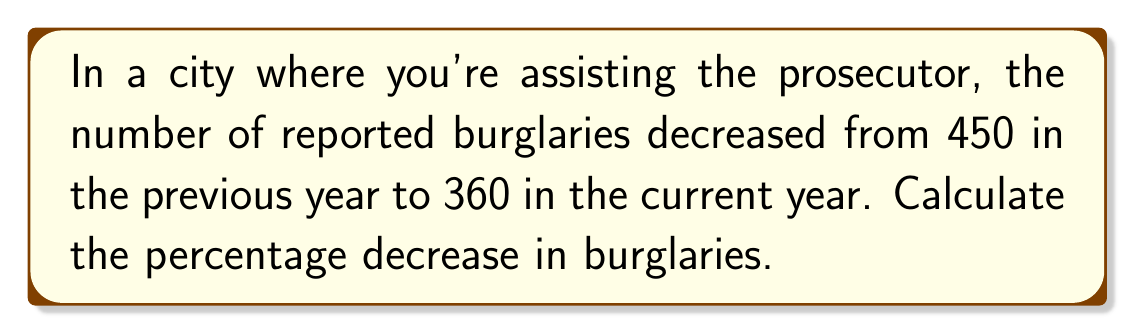Provide a solution to this math problem. To calculate the percentage decrease in burglaries, we'll follow these steps:

1. Calculate the difference between the previous year and current year:
   $450 - 360 = 90$

2. Divide the difference by the original (previous year) value:
   $\frac{90}{450} = 0.2$

3. Convert the decimal to a percentage by multiplying by 100:
   $0.2 \times 100 = 20\%$

The formula for percentage decrease is:

$$\text{Percentage Decrease} = \frac{\text{Decrease}}{\text{Original Value}} \times 100\%$$

Plugging in our values:

$$\text{Percentage Decrease} = \frac{450 - 360}{450} \times 100\% = \frac{90}{450} \times 100\% = 20\%$$

Therefore, the percentage decrease in burglaries is 20%.
Answer: 20% 